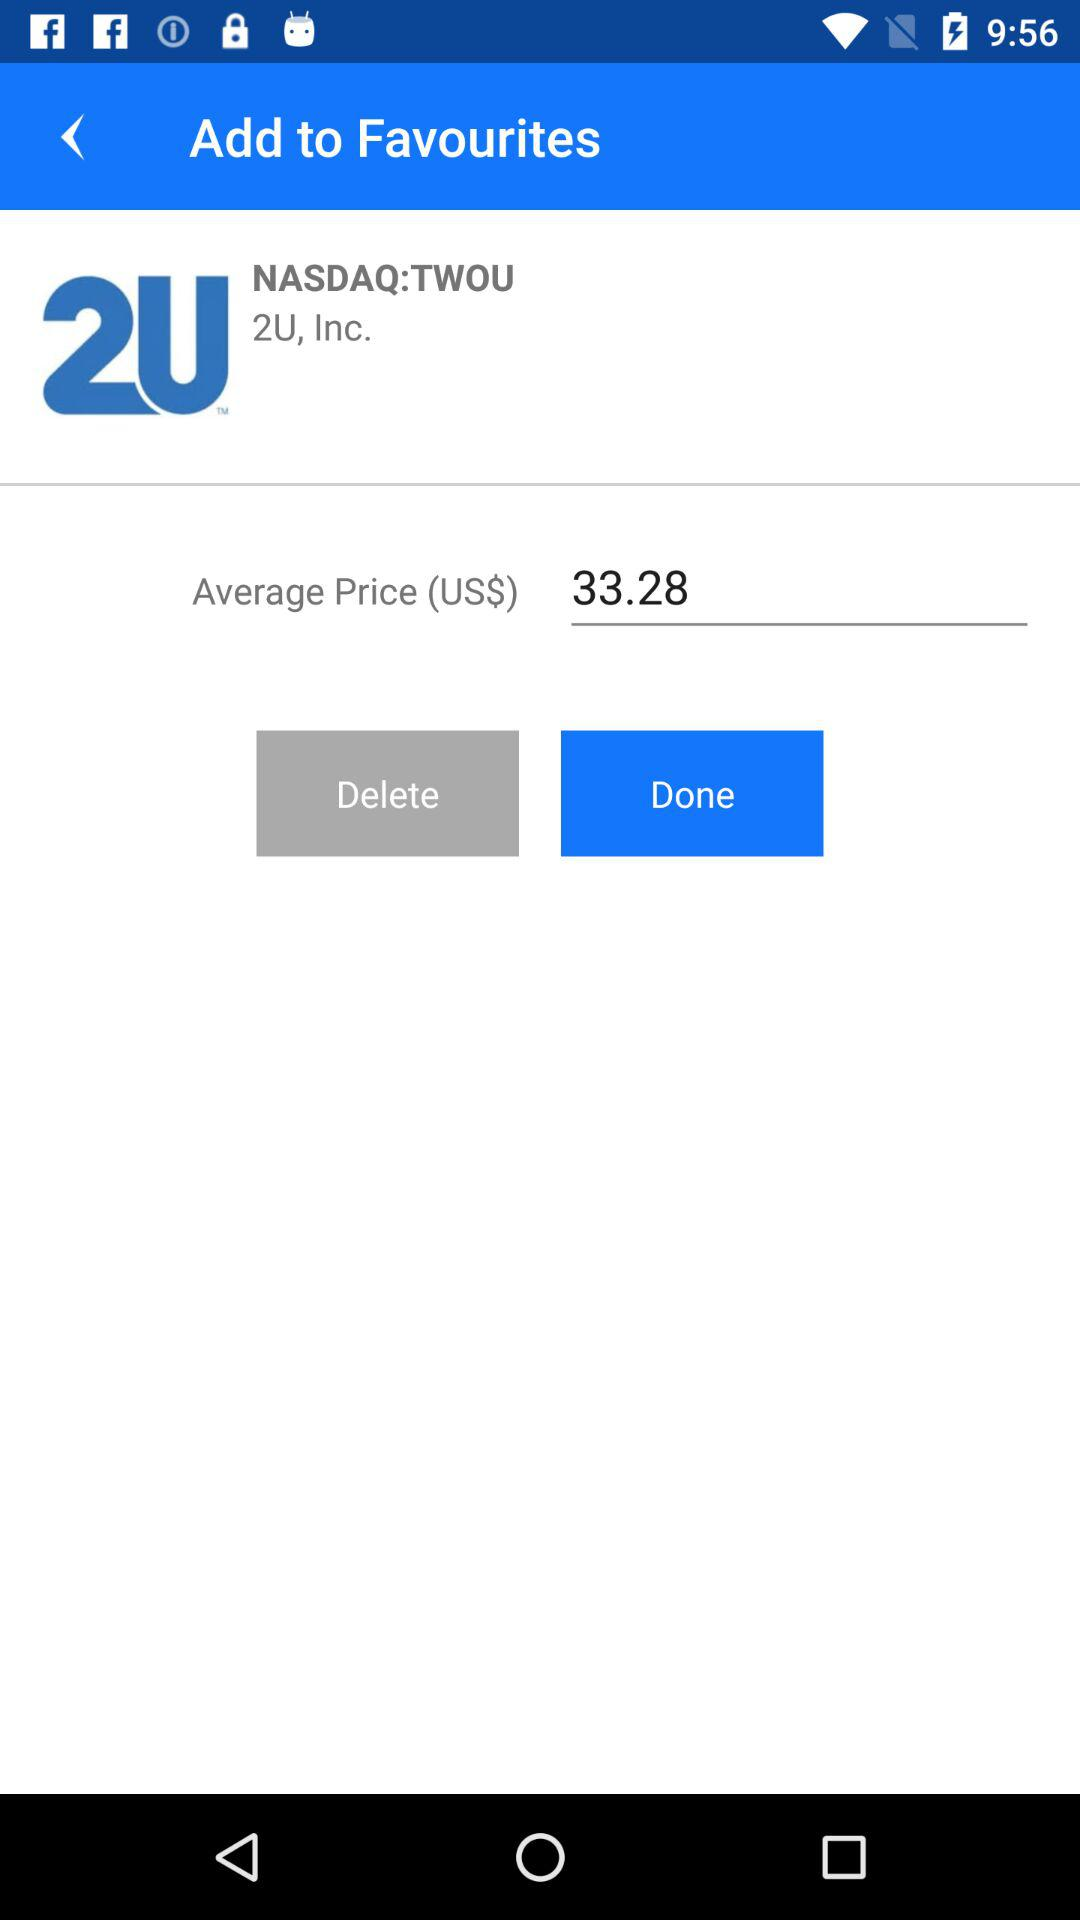What is the average price of the stock?
Answer the question using a single word or phrase. 33.28 